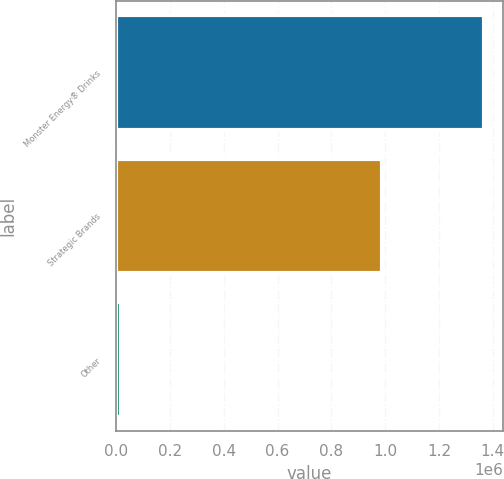Convert chart. <chart><loc_0><loc_0><loc_500><loc_500><bar_chart><fcel>Monster Energy® Drinks<fcel>Strategic Brands<fcel>Other<nl><fcel>1.36862e+06<fcel>989944<fcel>18957<nl></chart> 